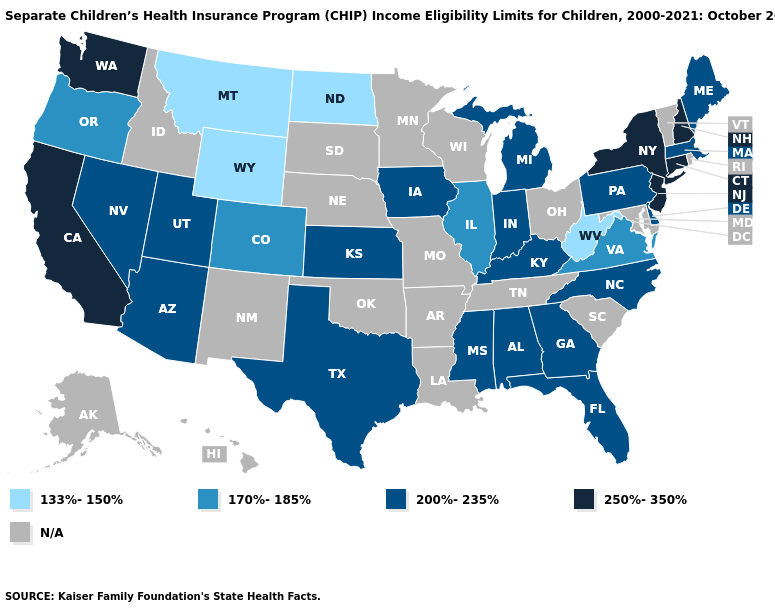Among the states that border West Virginia , which have the lowest value?
Answer briefly. Virginia. Which states hav the highest value in the West?
Give a very brief answer. California, Washington. Does the first symbol in the legend represent the smallest category?
Keep it brief. Yes. Name the states that have a value in the range 200%-235%?
Be succinct. Alabama, Arizona, Delaware, Florida, Georgia, Indiana, Iowa, Kansas, Kentucky, Maine, Massachusetts, Michigan, Mississippi, Nevada, North Carolina, Pennsylvania, Texas, Utah. What is the value of Delaware?
Short answer required. 200%-235%. Does Florida have the lowest value in the South?
Keep it brief. No. What is the value of North Dakota?
Concise answer only. 133%-150%. Does New York have the lowest value in the Northeast?
Keep it brief. No. Which states have the highest value in the USA?
Concise answer only. California, Connecticut, New Hampshire, New Jersey, New York, Washington. Name the states that have a value in the range 133%-150%?
Concise answer only. Montana, North Dakota, West Virginia, Wyoming. Which states hav the highest value in the Northeast?
Give a very brief answer. Connecticut, New Hampshire, New Jersey, New York. What is the value of Kansas?
Give a very brief answer. 200%-235%. What is the value of Arkansas?
Write a very short answer. N/A. Name the states that have a value in the range 170%-185%?
Write a very short answer. Colorado, Illinois, Oregon, Virginia. 